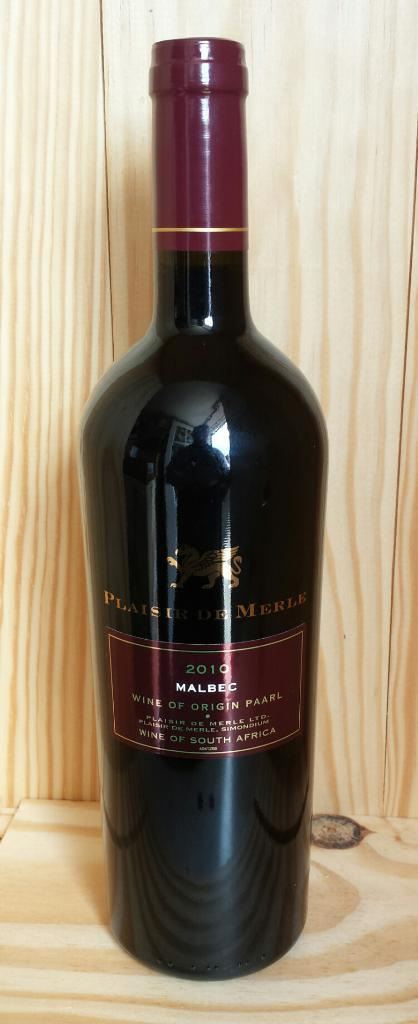<image>
Provide a brief description of the given image. A bottle of a 2010 Malbec sits on a wooden shelf. 